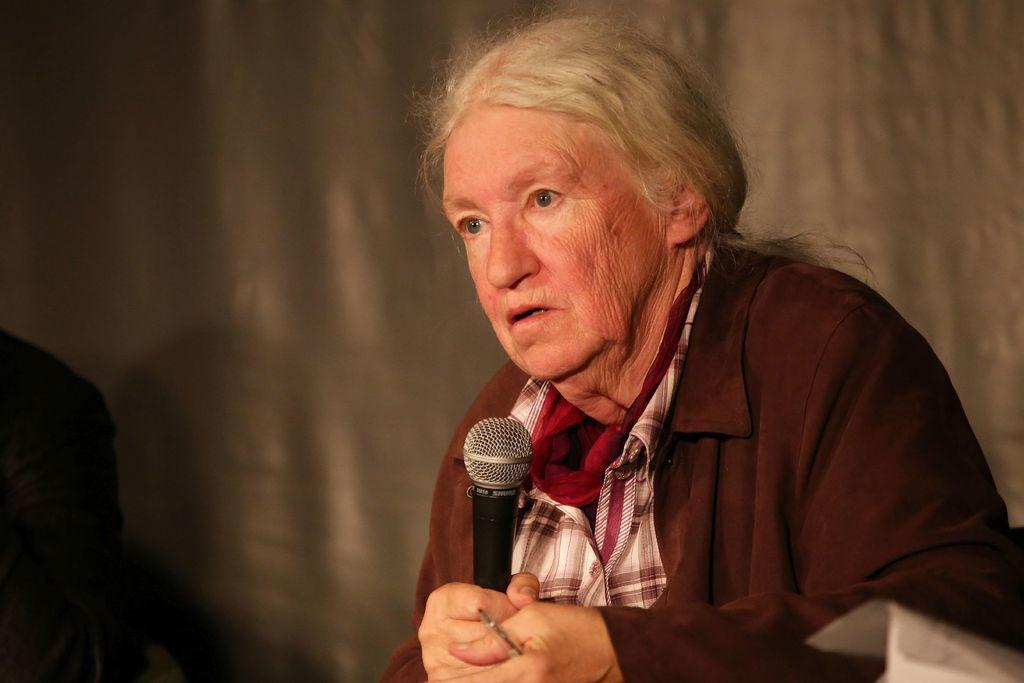Who is the main subject in the image? There is an old woman in the image. What is the old woman holding in her hand? The old woman is holding a mic in her hand. What color is the shirt the old woman is wearing? The old woman is wearing a red shirt. What can be seen in the background of the image? There is a wall in the background of the image. How many giants are present in the image? There are no giants present in the image; it features an old woman holding a mic. What type of loaf is the old woman using to hold the mic? There is no loaf present in the image; the old woman is holding the mic with her hand. 